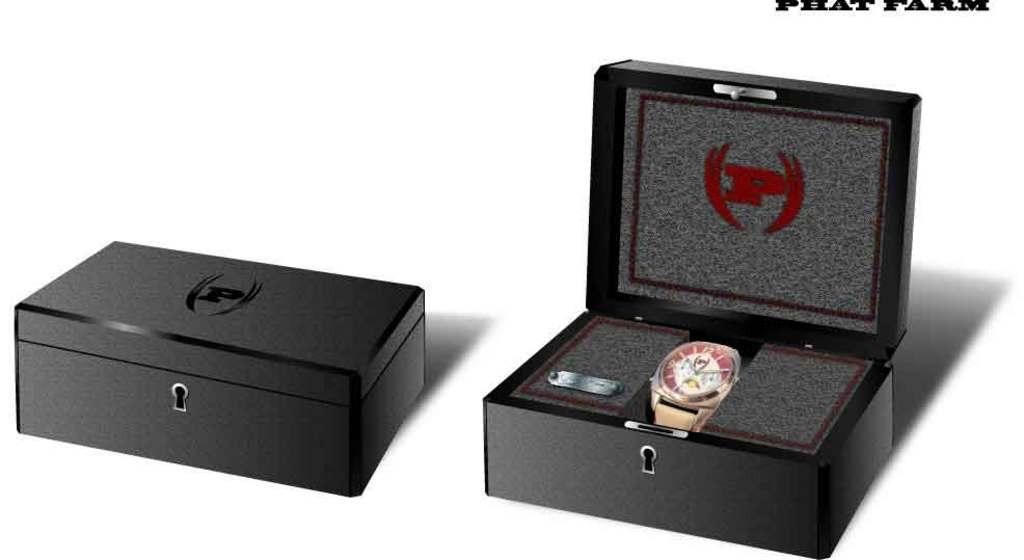What is the time is the watch set to?
Give a very brief answer. 10:10. What is the letter on the box?
Ensure brevity in your answer.  P. 